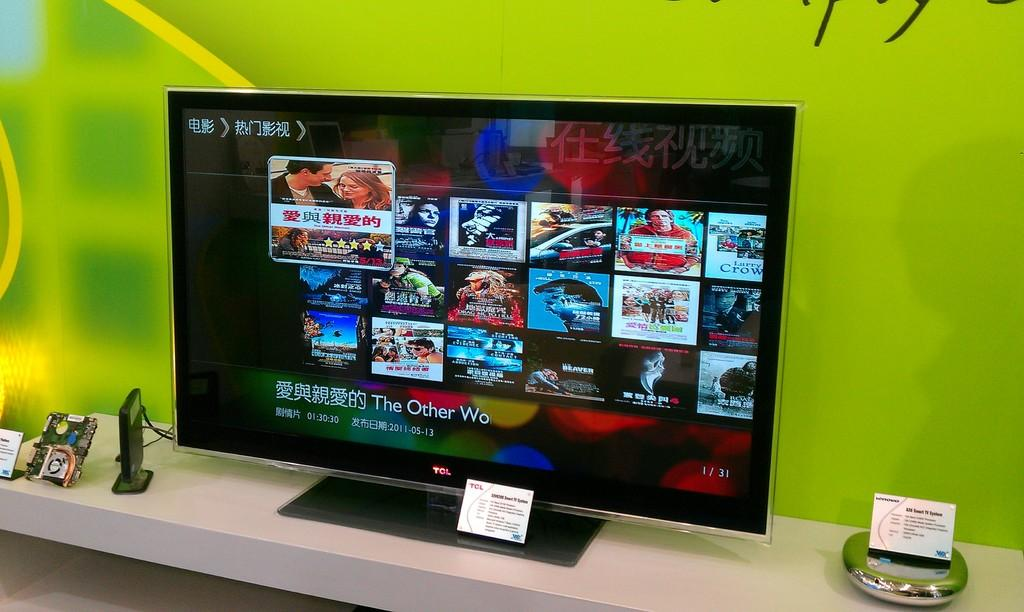<image>
Provide a brief description of the given image. tcl monitor or tv that has display of different movies on the screen such as larry crow and the beaver 